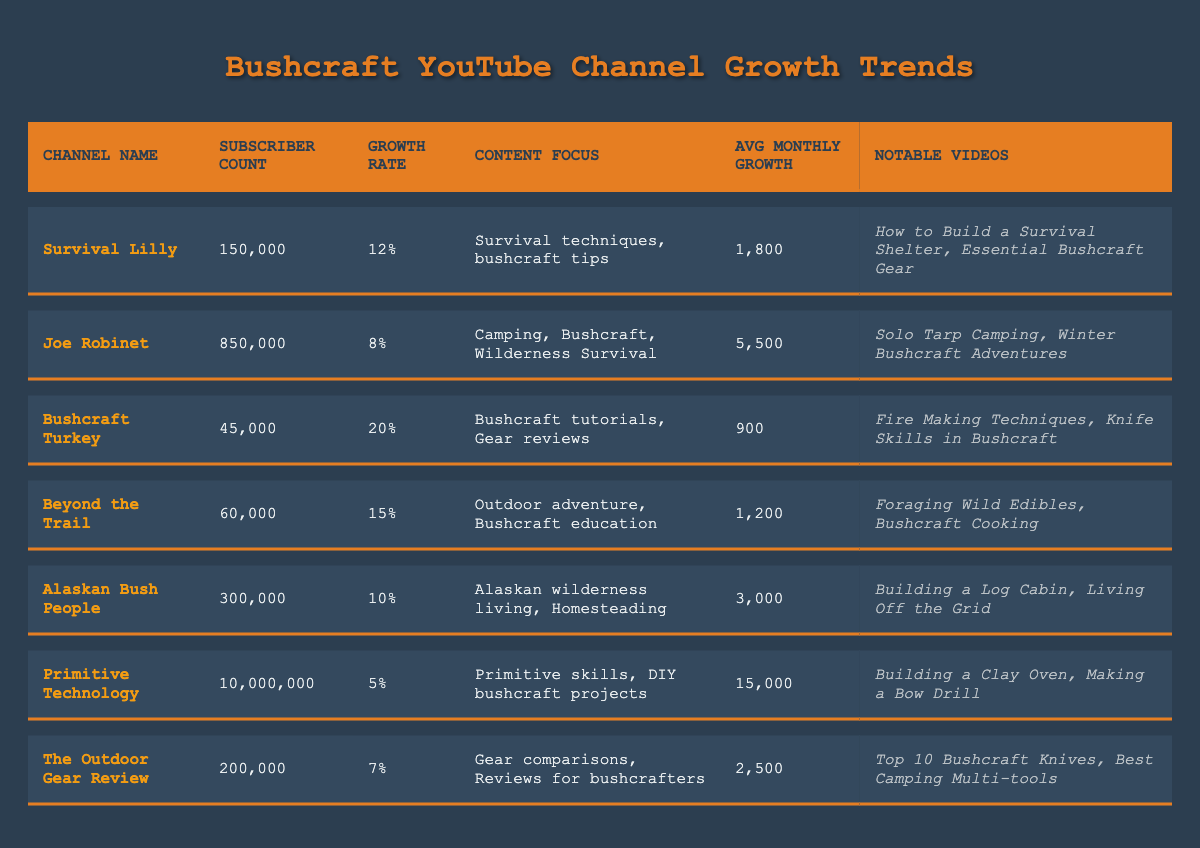What is the subscriber count of Joe Robinet? The table shows that Joe Robinet has a subscriber count listed next to his channel name, which is 850,000.
Answer: 850,000 Which channel has the highest growth rate? Looking through the Growth Rate column in the table, Bushcraft Turkey has the highest percentage, which is 20%.
Answer: 20% How many subscribers does Primitive Technology gain on average per month? In the Avg Monthly Growth column, the value next to Primitive Technology is 15,000, indicating its average growth per month.
Answer: 15,000 What is the combined subscriber count of Survival Lilly and Alaskan Bush People? Summing the subscriber counts of Survival Lilly (150,000) and Alaskan Bush People (300,000) gives 150,000 + 300,000 = 450,000.
Answer: 450,000 Which channel has the lowest subscriber count? By examining the Subscriber Count column, Bushcraft Turkey has the lowest count, which is 45,000.
Answer: 45,000 Is The Outdoor Gear Review's growth rate higher than Joe Robinet's? Comparing the Growth Rate values, The Outdoor Gear Review has a rate of 7%, while Joe Robinet has a rate of 8%, indicating that The Outdoor Gear Review's growth rate is lower.
Answer: No What is the average growth rate of all channels listed? To find the average, we sum all growth rates as integers: 12 + 8 + 20 + 15 + 10 + 5 + 7 = 77. There are 7 channels, so the average is 77/7 ≈ 11%.
Answer: Approximately 11% If you compare Survival Lilly and Beyond the Trail, which channel has a higher average monthly growth? Looking at Avg Monthly Growth, Survival Lilly has 1,800 and Beyond the Trail 1,200; thus, Survival Lilly has a higher value.
Answer: Survival Lilly How many total subscribers do the top three channels (by subscriber count) have combined? The top three channels are Primitive Technology (10,000,000), Joe Robinet (850,000), and Alaskan Bush People (300,000). Summing yields 10,000,000 + 850,000 + 300,000 = 11,150,000.
Answer: 11,150,000 Does Bushcraft Turkey have more subscribers than Beyond the Trail? Bushcraft Turkey's subscriber count is 45,000, while Beyond the Trail has 60,000, indicating Bushcraft Turkey has fewer subscribers.
Answer: No 